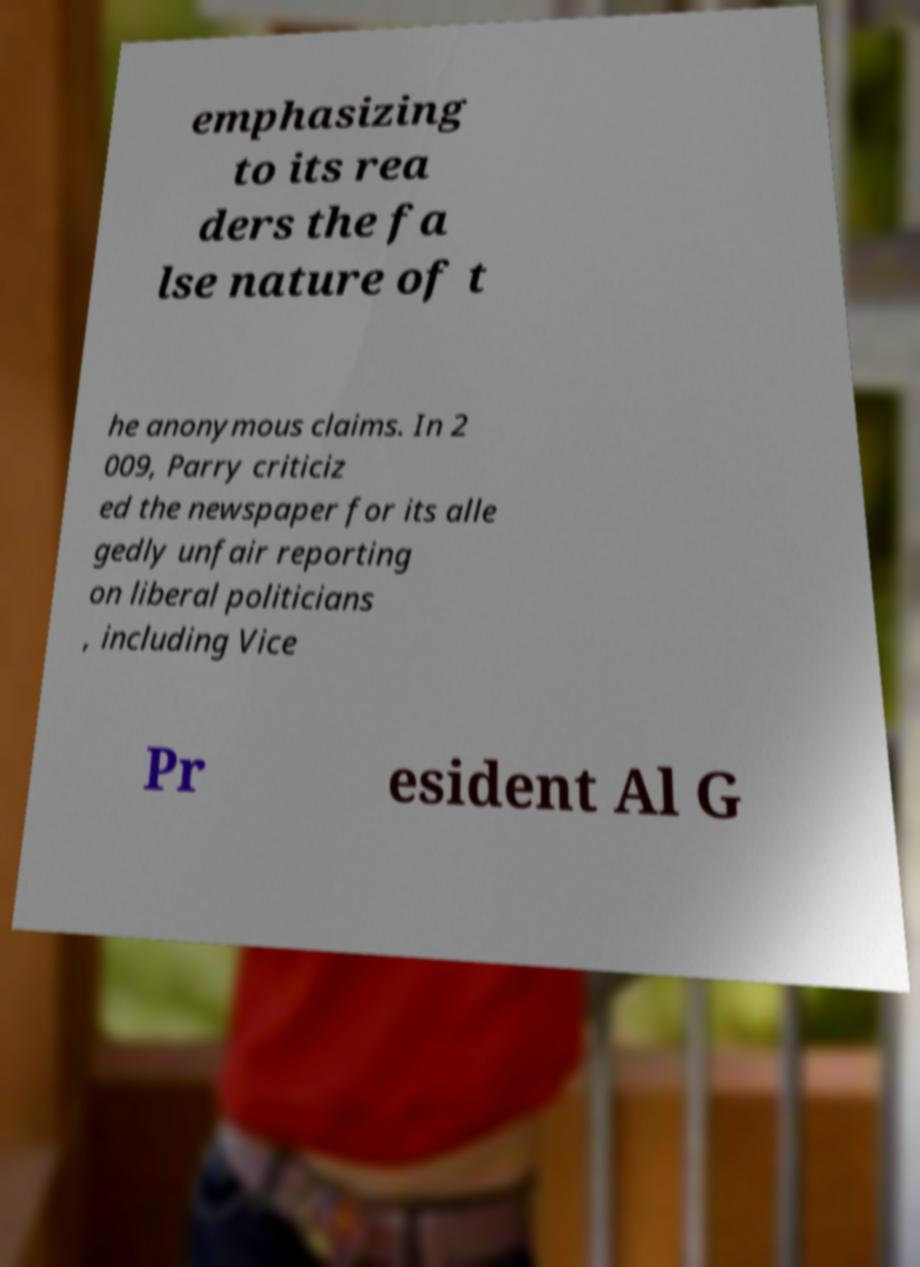Please read and relay the text visible in this image. What does it say? emphasizing to its rea ders the fa lse nature of t he anonymous claims. In 2 009, Parry criticiz ed the newspaper for its alle gedly unfair reporting on liberal politicians , including Vice Pr esident Al G 